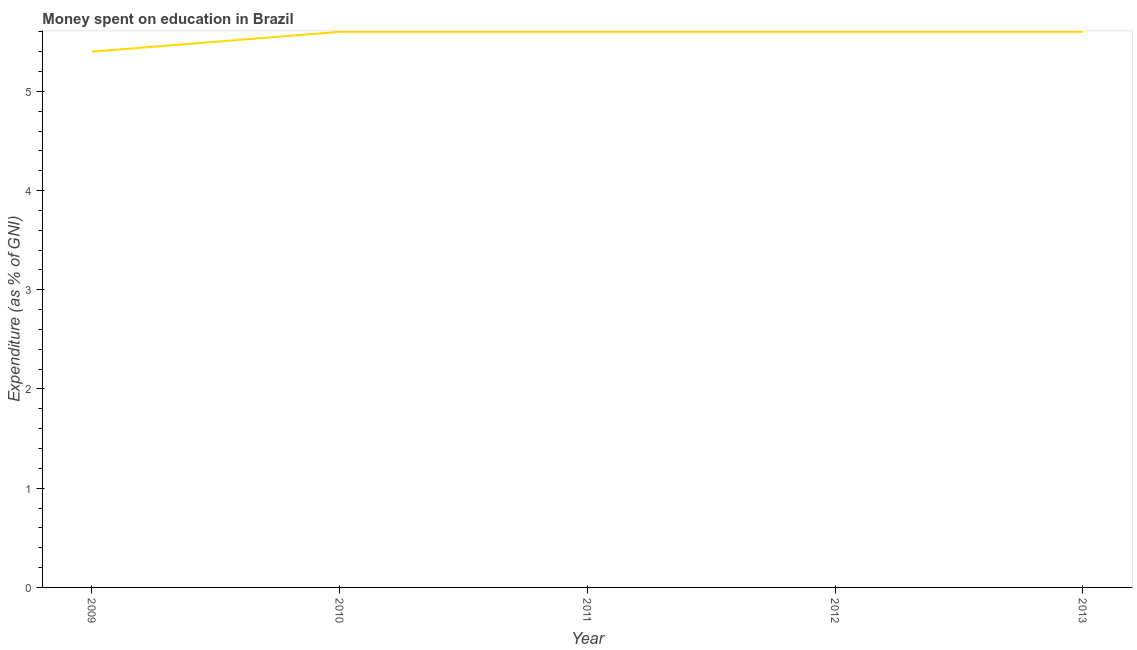What is the expenditure on education in 2009?
Make the answer very short. 5.4. Across all years, what is the maximum expenditure on education?
Ensure brevity in your answer.  5.6. In which year was the expenditure on education minimum?
Make the answer very short. 2009. What is the sum of the expenditure on education?
Make the answer very short. 27.8. What is the difference between the expenditure on education in 2009 and 2012?
Make the answer very short. -0.2. What is the average expenditure on education per year?
Offer a terse response. 5.56. What is the median expenditure on education?
Provide a succinct answer. 5.6. In how many years, is the expenditure on education greater than 3.4 %?
Keep it short and to the point. 5. Do a majority of the years between 2010 and 2011 (inclusive) have expenditure on education greater than 1.8 %?
Your response must be concise. Yes. What is the ratio of the expenditure on education in 2011 to that in 2013?
Provide a succinct answer. 1. Is the expenditure on education in 2010 less than that in 2012?
Your response must be concise. No. Is the difference between the expenditure on education in 2010 and 2011 greater than the difference between any two years?
Ensure brevity in your answer.  No. What is the difference between the highest and the second highest expenditure on education?
Offer a terse response. 0. Is the sum of the expenditure on education in 2010 and 2012 greater than the maximum expenditure on education across all years?
Ensure brevity in your answer.  Yes. What is the difference between the highest and the lowest expenditure on education?
Make the answer very short. 0.2. Does the expenditure on education monotonically increase over the years?
Your response must be concise. No. How many lines are there?
Offer a terse response. 1. How many years are there in the graph?
Your answer should be very brief. 5. What is the difference between two consecutive major ticks on the Y-axis?
Your answer should be very brief. 1. Are the values on the major ticks of Y-axis written in scientific E-notation?
Ensure brevity in your answer.  No. Does the graph contain any zero values?
Your answer should be compact. No. What is the title of the graph?
Your response must be concise. Money spent on education in Brazil. What is the label or title of the Y-axis?
Provide a succinct answer. Expenditure (as % of GNI). What is the Expenditure (as % of GNI) in 2009?
Your answer should be very brief. 5.4. What is the Expenditure (as % of GNI) in 2012?
Offer a very short reply. 5.6. What is the Expenditure (as % of GNI) in 2013?
Your answer should be compact. 5.6. What is the difference between the Expenditure (as % of GNI) in 2009 and 2010?
Offer a terse response. -0.2. What is the difference between the Expenditure (as % of GNI) in 2009 and 2011?
Give a very brief answer. -0.2. What is the difference between the Expenditure (as % of GNI) in 2010 and 2012?
Provide a short and direct response. 0. What is the difference between the Expenditure (as % of GNI) in 2011 and 2012?
Provide a short and direct response. 0. What is the difference between the Expenditure (as % of GNI) in 2011 and 2013?
Offer a very short reply. 0. What is the difference between the Expenditure (as % of GNI) in 2012 and 2013?
Keep it short and to the point. 0. What is the ratio of the Expenditure (as % of GNI) in 2009 to that in 2010?
Make the answer very short. 0.96. What is the ratio of the Expenditure (as % of GNI) in 2009 to that in 2011?
Offer a very short reply. 0.96. What is the ratio of the Expenditure (as % of GNI) in 2010 to that in 2011?
Provide a short and direct response. 1. What is the ratio of the Expenditure (as % of GNI) in 2010 to that in 2012?
Offer a very short reply. 1. What is the ratio of the Expenditure (as % of GNI) in 2010 to that in 2013?
Offer a terse response. 1. What is the ratio of the Expenditure (as % of GNI) in 2011 to that in 2013?
Give a very brief answer. 1. 